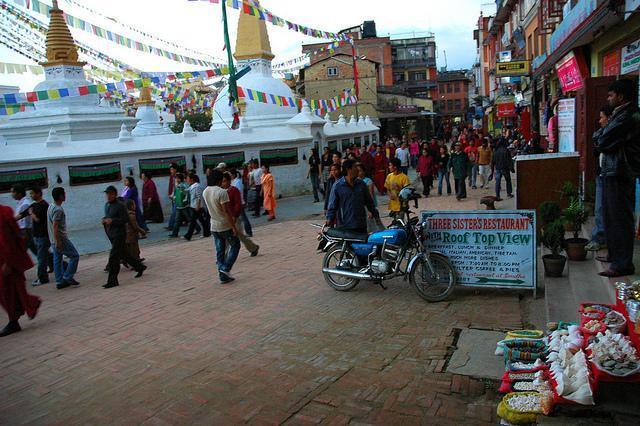How many steps are there on the right?
Give a very brief answer. 3. How many people are in the picture?
Give a very brief answer. 4. 